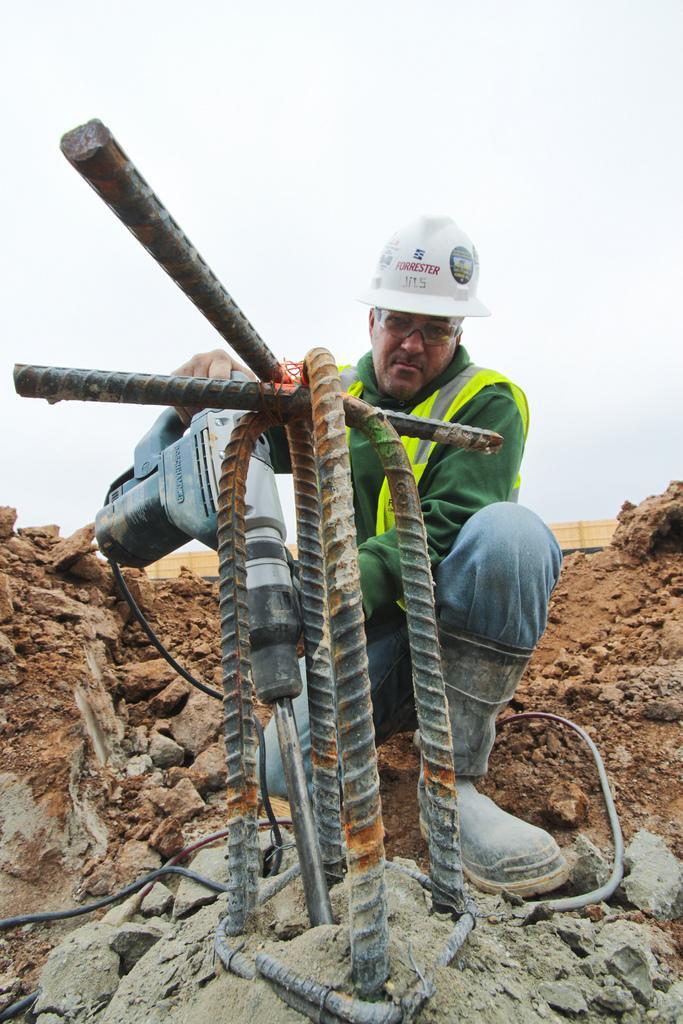Can you describe this image briefly? In this image I can see in the middle there are iron bars, a man is drilling with a drilling machine, this man wear a helmet. At the top it is the sky. 